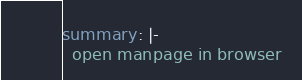<code> <loc_0><loc_0><loc_500><loc_500><_YAML_>summary: |-
  open manpage in browser
</code> 